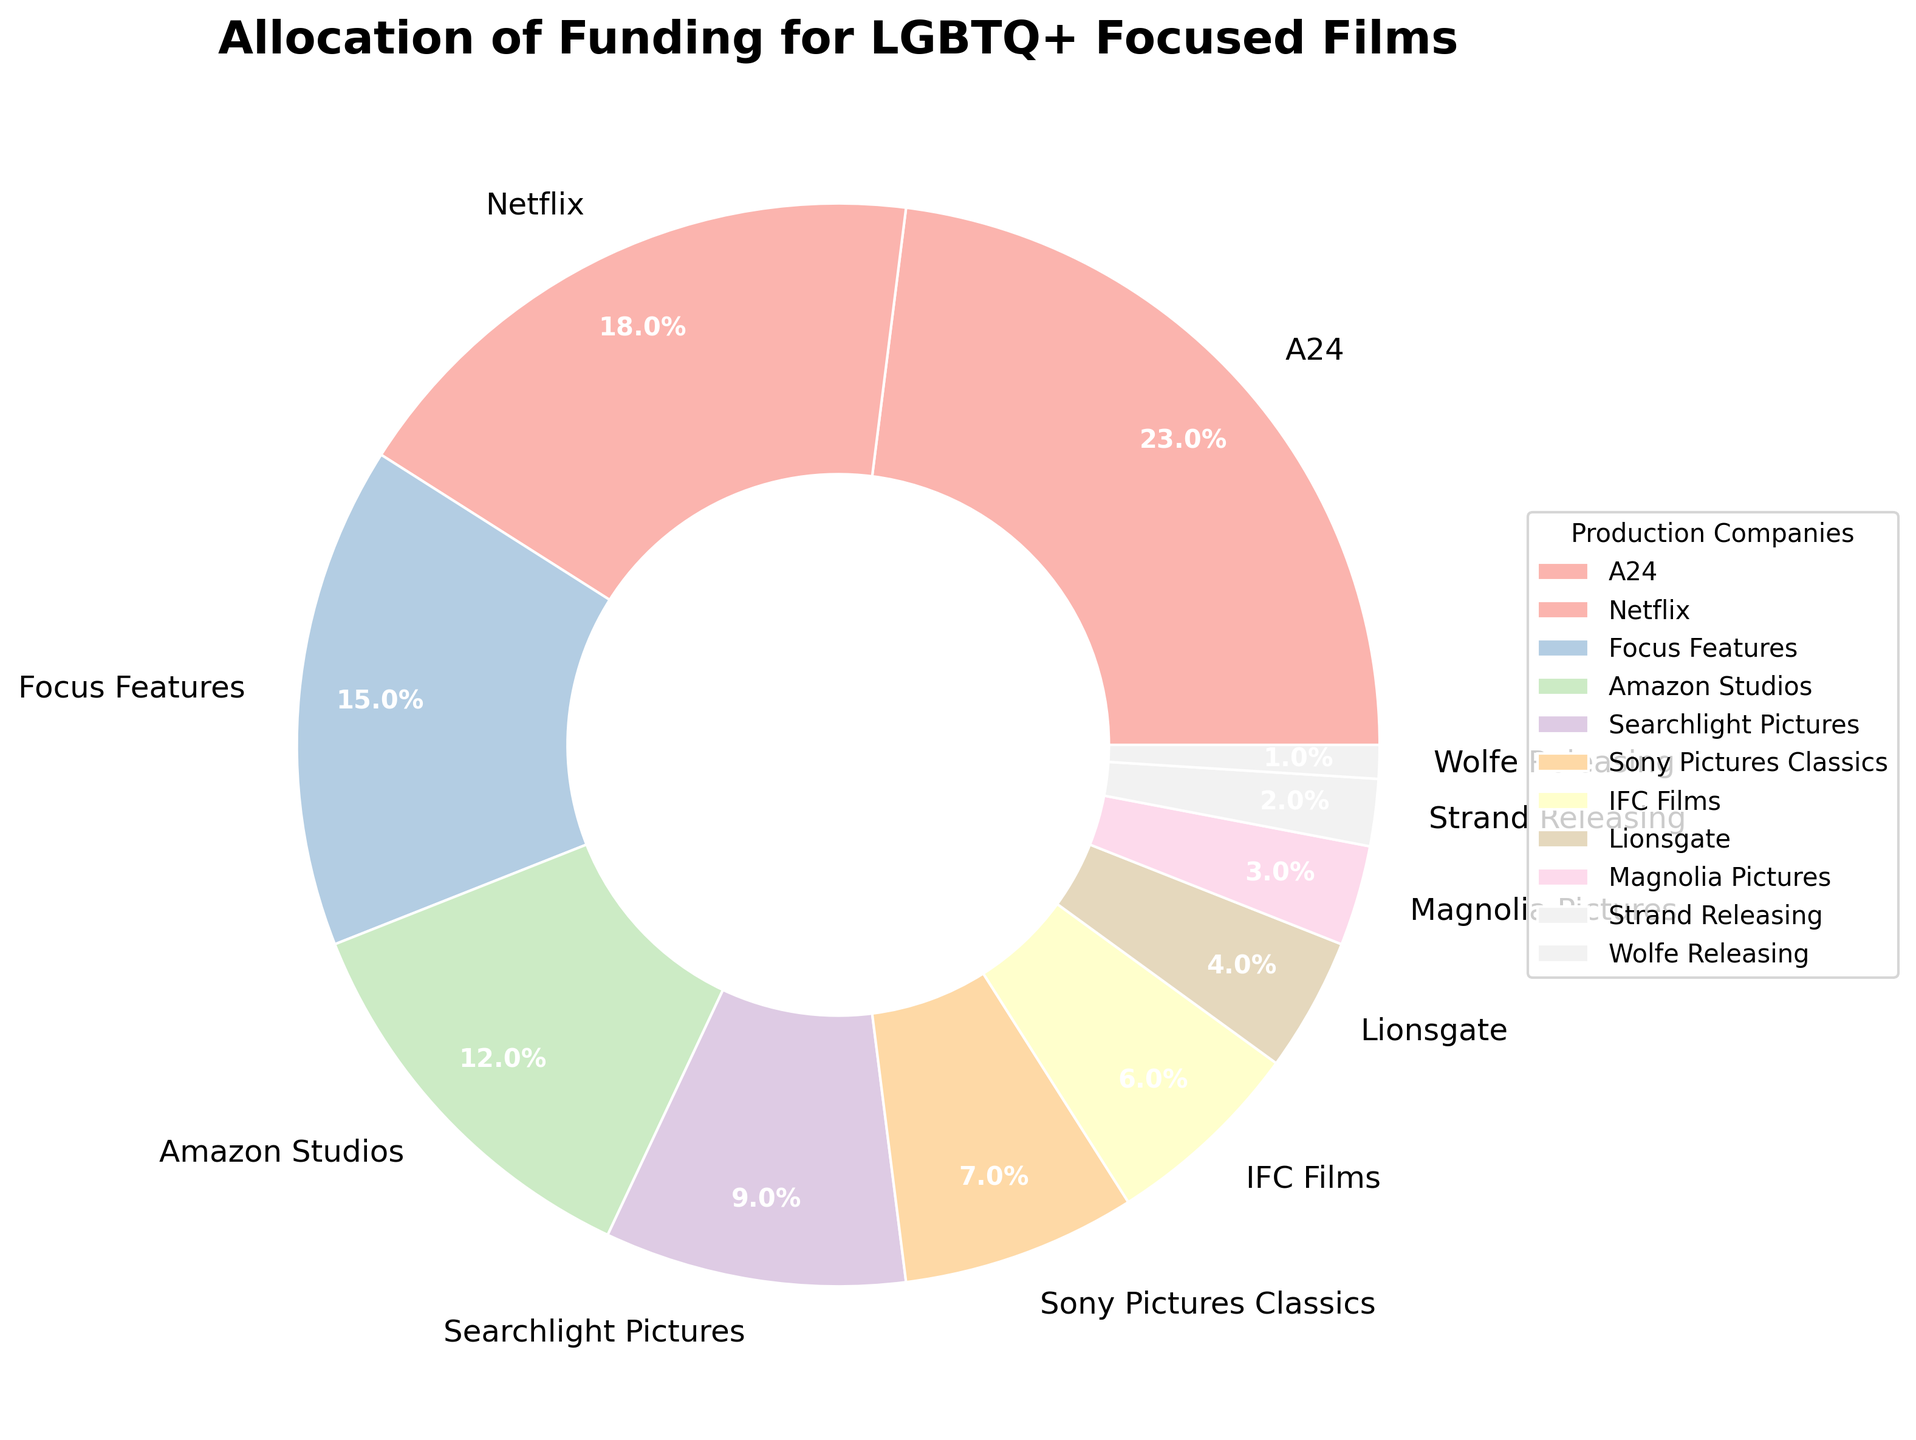Which production company allocated the highest percentage of funding for LGBTQ+ focused films? The wedge for A24 shows the highest percentage, 23%.
Answer: A24 What is the combined funding allocation percentage of Focus Features and Amazon Studios? Focus Features has 15% and Amazon Studios has 12%. Adding them together gives 15% + 12% = 27%.
Answer: 27% Which production company allocated the least percentage of funding? The wedge for Wolfe Releasing shows the lowest percentage, 1%.
Answer: Wolfe Releasing How much more funding did Netflix allocate compared to Lionsgate? Netflix allocated 18% and Lionsgate allocated 4%. The difference is 18% - 4% = 14%.
Answer: 14% What is the average funding allocation percentage across all production companies? Summing all percentages: 23 + 18 + 15 + 12 + 9 + 7 + 6 + 4 + 3 + 2 + 1 = 100%. The average is 100% / 11 = 9.09%.
Answer: 9.09% Which company allocated more funding: Searchlight Pictures or Sony Pictures Classics? Searchlight Pictures allocated 9%, whereas Sony Pictures Classics allocated 7%. 9% is greater than 7%.
Answer: Searchlight Pictures What is the percentage difference between the highest and lowest funding allocations? The highest allocation is A24 with 23%, and the lowest is Wolfe Releasing with 1%. The difference is 23% - 1% = 22%.
Answer: 22% How many companies allocated more than 10% of their funding? The companies with allocations greater than 10% are A24 (23%), Netflix (18%), Focus Features (15%), and Amazon Studios (12%). There are 4 companies in total.
Answer: 4 What percentage of the total funding allocations is made up by the three smallest companies? The three smallest companies are Strand Releasing (2%), Magnolia Pictures (3%), and Wolfe Releasing (1%). The total is 2% + 3% + 1% = 6%.
Answer: 6% Which company, IFC Films or Lionsgate, has a higher funding allocation, and by how much? IFC Films has a funding allocation of 6% while Lionsgate has 4%. The difference is 6% - 4% = 2%.
Answer: IFC Films, 2% 